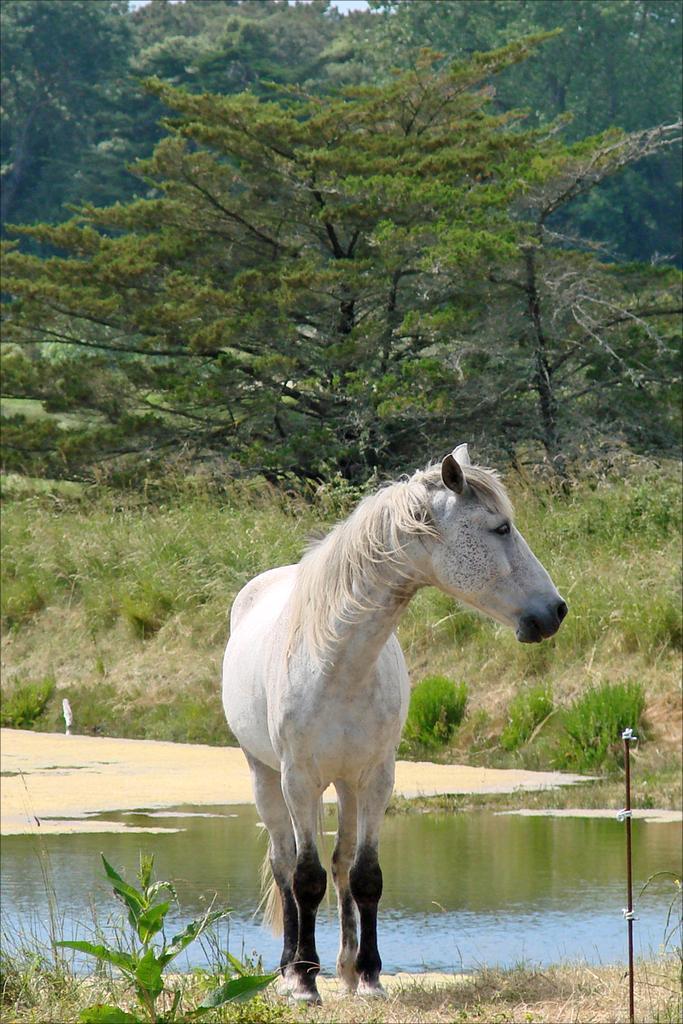Could you give a brief overview of what you see in this image? In this image, we can see a horse and in the background, there are trees. At the bottom, there is water and ground covered with grass. 